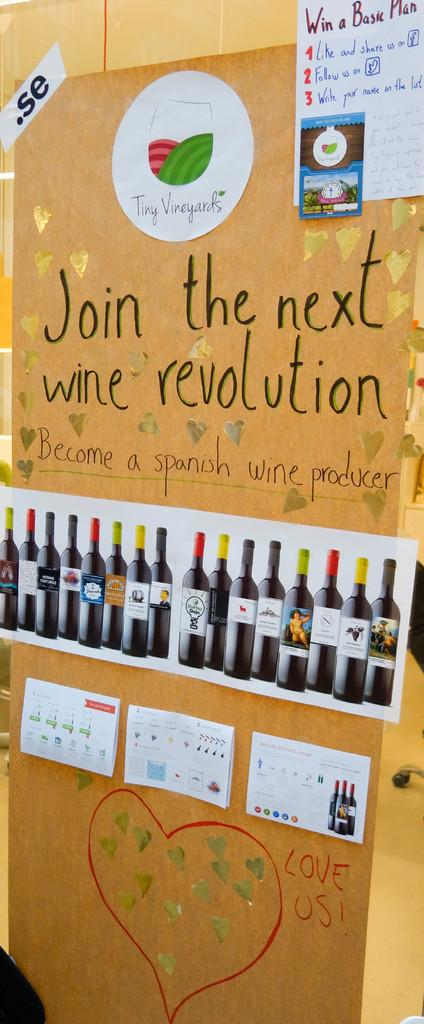<image>
Describe the image concisely. A handwritten poster, urging people to "join the next wine revolution," has a heart drawn on it. 